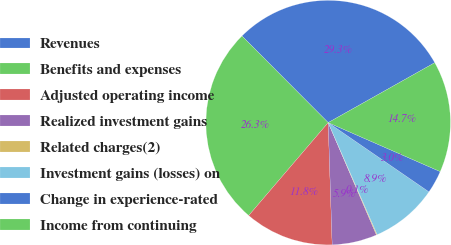<chart> <loc_0><loc_0><loc_500><loc_500><pie_chart><fcel>Revenues<fcel>Benefits and expenses<fcel>Adjusted operating income<fcel>Realized investment gains<fcel>Related charges(2)<fcel>Investment gains (losses) on<fcel>Change in experience-rated<fcel>Income from continuing<nl><fcel>29.31%<fcel>26.27%<fcel>11.78%<fcel>5.94%<fcel>0.1%<fcel>8.86%<fcel>3.02%<fcel>14.71%<nl></chart> 